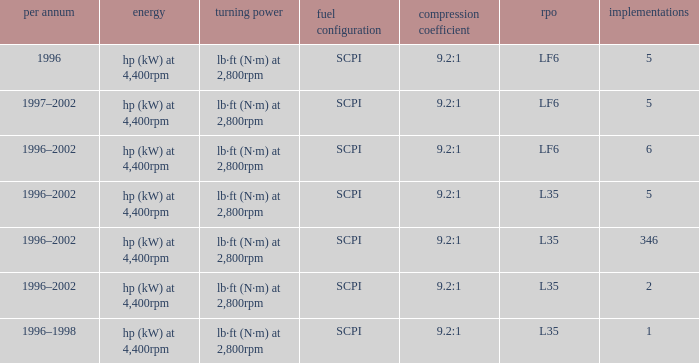What's the compression ratio of the model with L35 RPO and 5 applications? 9.2:1. 